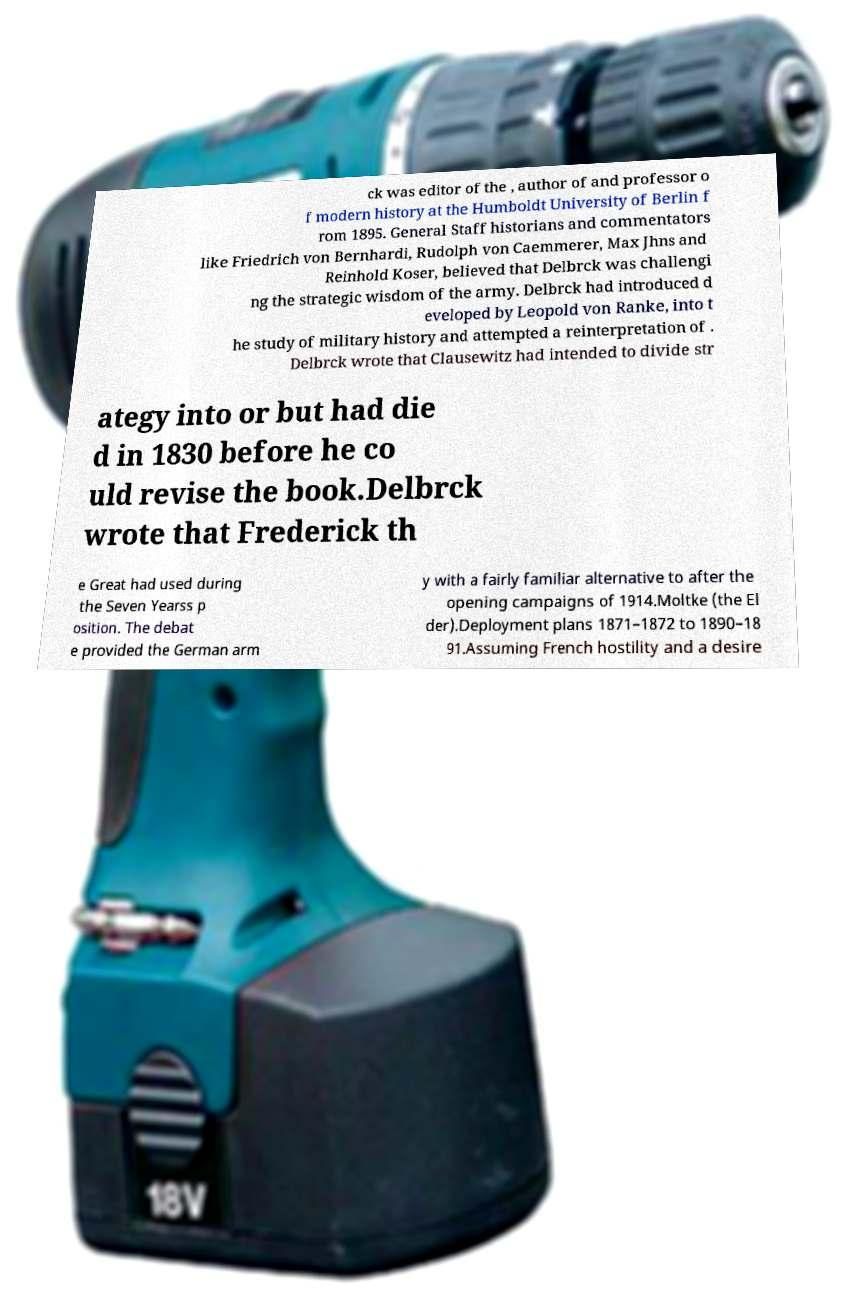Can you read and provide the text displayed in the image?This photo seems to have some interesting text. Can you extract and type it out for me? ck was editor of the , author of and professor o f modern history at the Humboldt University of Berlin f rom 1895. General Staff historians and commentators like Friedrich von Bernhardi, Rudolph von Caemmerer, Max Jhns and Reinhold Koser, believed that Delbrck was challengi ng the strategic wisdom of the army. Delbrck had introduced d eveloped by Leopold von Ranke, into t he study of military history and attempted a reinterpretation of . Delbrck wrote that Clausewitz had intended to divide str ategy into or but had die d in 1830 before he co uld revise the book.Delbrck wrote that Frederick th e Great had used during the Seven Yearss p osition. The debat e provided the German arm y with a fairly familiar alternative to after the opening campaigns of 1914.Moltke (the El der).Deployment plans 1871–1872 to 1890–18 91.Assuming French hostility and a desire 